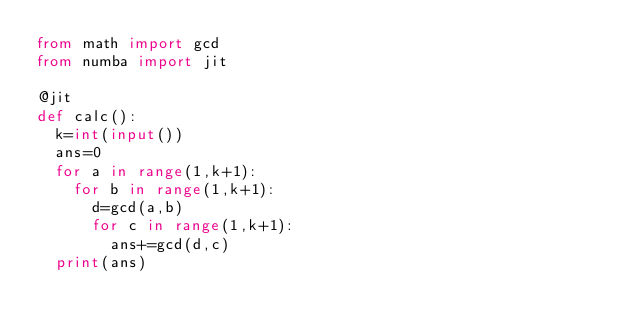<code> <loc_0><loc_0><loc_500><loc_500><_Python_>from math import gcd
from numba import jit

@jit
def calc(): 
  k=int(input())
  ans=0
  for a in range(1,k+1):
    for b in range(1,k+1):
      d=gcd(a,b)
      for c in range(1,k+1):
        ans+=gcd(d,c)
  print(ans)
</code> 